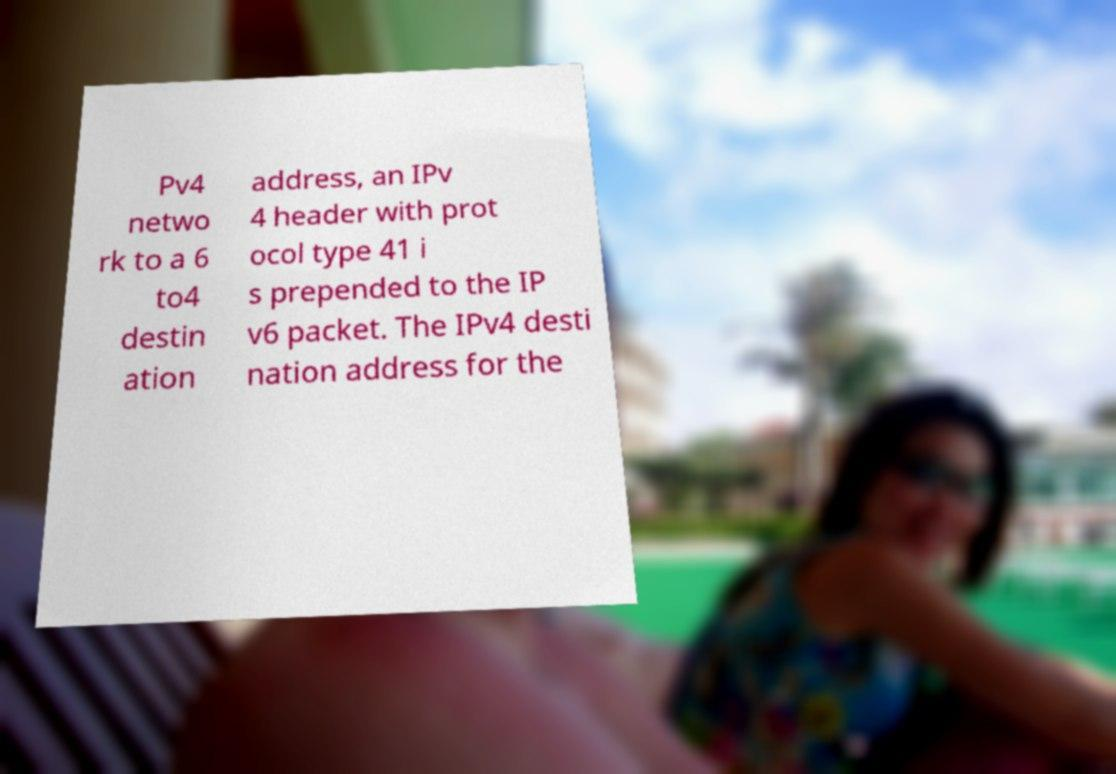For documentation purposes, I need the text within this image transcribed. Could you provide that? Pv4 netwo rk to a 6 to4 destin ation address, an IPv 4 header with prot ocol type 41 i s prepended to the IP v6 packet. The IPv4 desti nation address for the 